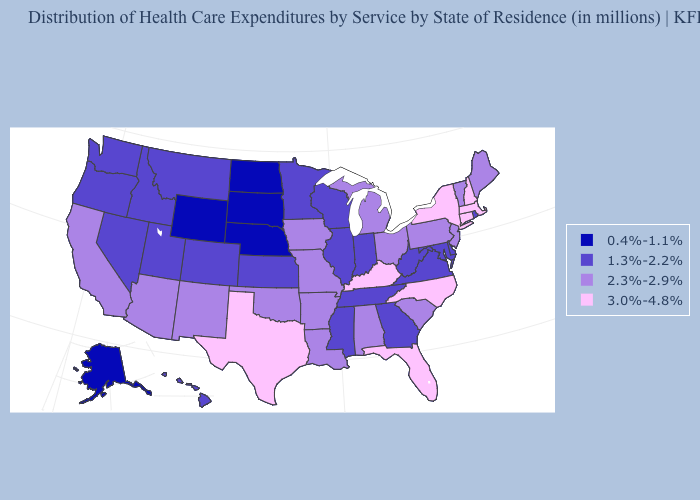Name the states that have a value in the range 1.3%-2.2%?
Be succinct. Colorado, Delaware, Georgia, Hawaii, Idaho, Illinois, Indiana, Kansas, Maryland, Minnesota, Mississippi, Montana, Nevada, Oregon, Rhode Island, Tennessee, Utah, Virginia, Washington, West Virginia, Wisconsin. What is the lowest value in the USA?
Concise answer only. 0.4%-1.1%. What is the value of Connecticut?
Write a very short answer. 3.0%-4.8%. What is the highest value in states that border Minnesota?
Keep it brief. 2.3%-2.9%. Name the states that have a value in the range 1.3%-2.2%?
Keep it brief. Colorado, Delaware, Georgia, Hawaii, Idaho, Illinois, Indiana, Kansas, Maryland, Minnesota, Mississippi, Montana, Nevada, Oregon, Rhode Island, Tennessee, Utah, Virginia, Washington, West Virginia, Wisconsin. Name the states that have a value in the range 0.4%-1.1%?
Short answer required. Alaska, Nebraska, North Dakota, South Dakota, Wyoming. Among the states that border California , which have the highest value?
Quick response, please. Arizona. Does Virginia have a lower value than Minnesota?
Give a very brief answer. No. Among the states that border Montana , does Idaho have the highest value?
Give a very brief answer. Yes. Among the states that border Alabama , which have the highest value?
Quick response, please. Florida. Among the states that border Nevada , which have the lowest value?
Give a very brief answer. Idaho, Oregon, Utah. What is the highest value in states that border Utah?
Concise answer only. 2.3%-2.9%. Does the map have missing data?
Answer briefly. No. What is the value of Kansas?
Answer briefly. 1.3%-2.2%. What is the value of Illinois?
Concise answer only. 1.3%-2.2%. 